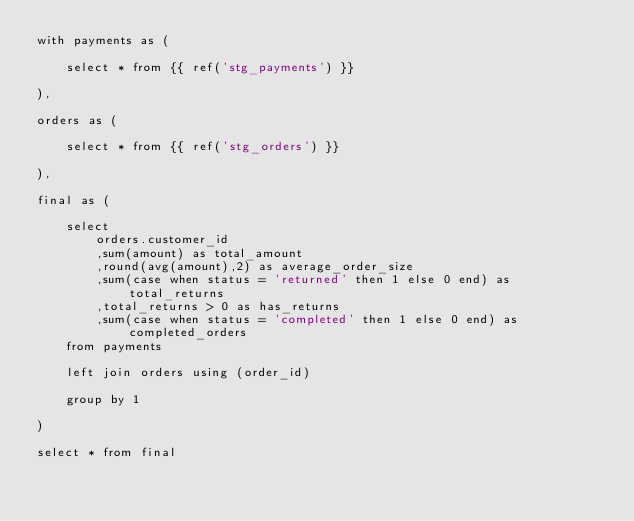<code> <loc_0><loc_0><loc_500><loc_500><_SQL_>with payments as (

    select * from {{ ref('stg_payments') }}

),

orders as (

    select * from {{ ref('stg_orders') }}

),

final as (

    select
        orders.customer_id
        ,sum(amount) as total_amount
        ,round(avg(amount),2) as average_order_size
        ,sum(case when status = 'returned' then 1 else 0 end) as total_returns
        ,total_returns > 0 as has_returns
        ,sum(case when status = 'completed' then 1 else 0 end) as completed_orders
    from payments

    left join orders using (order_id)

    group by 1

)

select * from final
</code> 